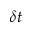<formula> <loc_0><loc_0><loc_500><loc_500>\delta t</formula> 